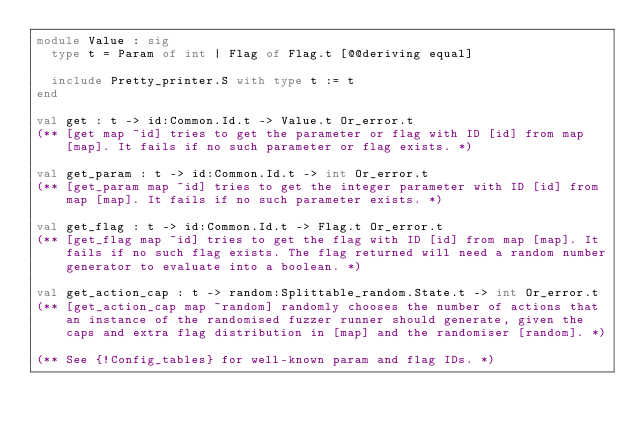<code> <loc_0><loc_0><loc_500><loc_500><_OCaml_>module Value : sig
  type t = Param of int | Flag of Flag.t [@@deriving equal]

  include Pretty_printer.S with type t := t
end

val get : t -> id:Common.Id.t -> Value.t Or_error.t
(** [get map ~id] tries to get the parameter or flag with ID [id] from map
    [map]. It fails if no such parameter or flag exists. *)

val get_param : t -> id:Common.Id.t -> int Or_error.t
(** [get_param map ~id] tries to get the integer parameter with ID [id] from
    map [map]. It fails if no such parameter exists. *)

val get_flag : t -> id:Common.Id.t -> Flag.t Or_error.t
(** [get_flag map ~id] tries to get the flag with ID [id] from map [map]. It
    fails if no such flag exists. The flag returned will need a random number
    generator to evaluate into a boolean. *)

val get_action_cap : t -> random:Splittable_random.State.t -> int Or_error.t
(** [get_action_cap map ~random] randomly chooses the number of actions that
    an instance of the randomised fuzzer runner should generate, given the
    caps and extra flag distribution in [map] and the randomiser [random]. *)

(** See {!Config_tables} for well-known param and flag IDs. *)
</code> 